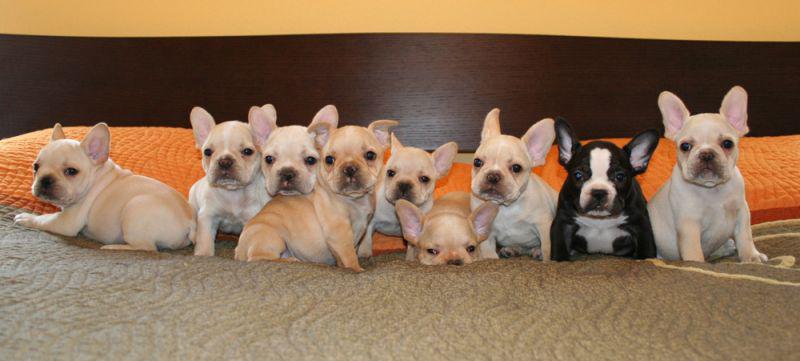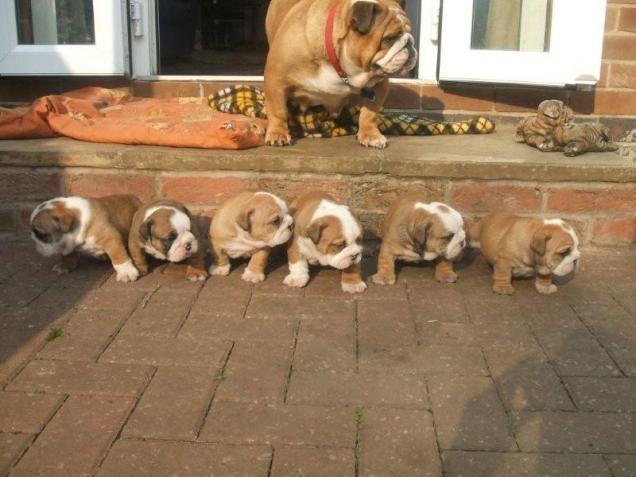The first image is the image on the left, the second image is the image on the right. Analyze the images presented: Is the assertion "The dogs on the left are lined up." valid? Answer yes or no. Yes. 